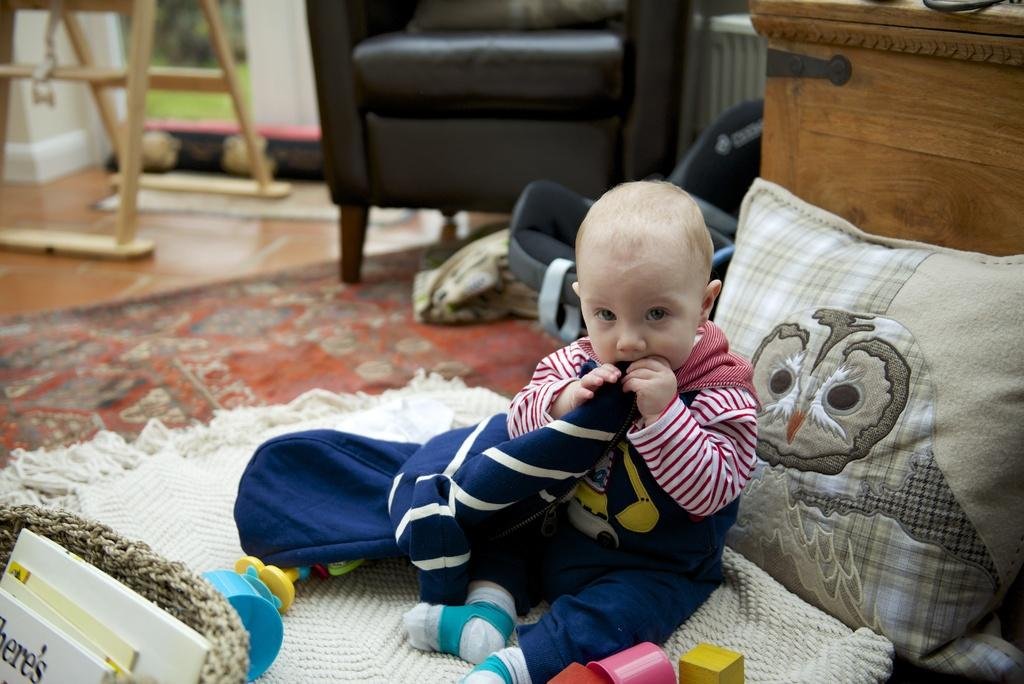What is the boy in the image doing? The boy is sitting on the floor and playing with toys. What can be seen in the background of the image? There is a sofa and a wooden table in the background. What is located near the wooden table? There is a basket filled with books near the wooden table. What type of cattle can be seen grazing in the background of the image? There are no cattle present in the image; it features a boy playing with toys and a background with a sofa and wooden table. 